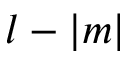Convert formula to latex. <formula><loc_0><loc_0><loc_500><loc_500>l - | m |</formula> 